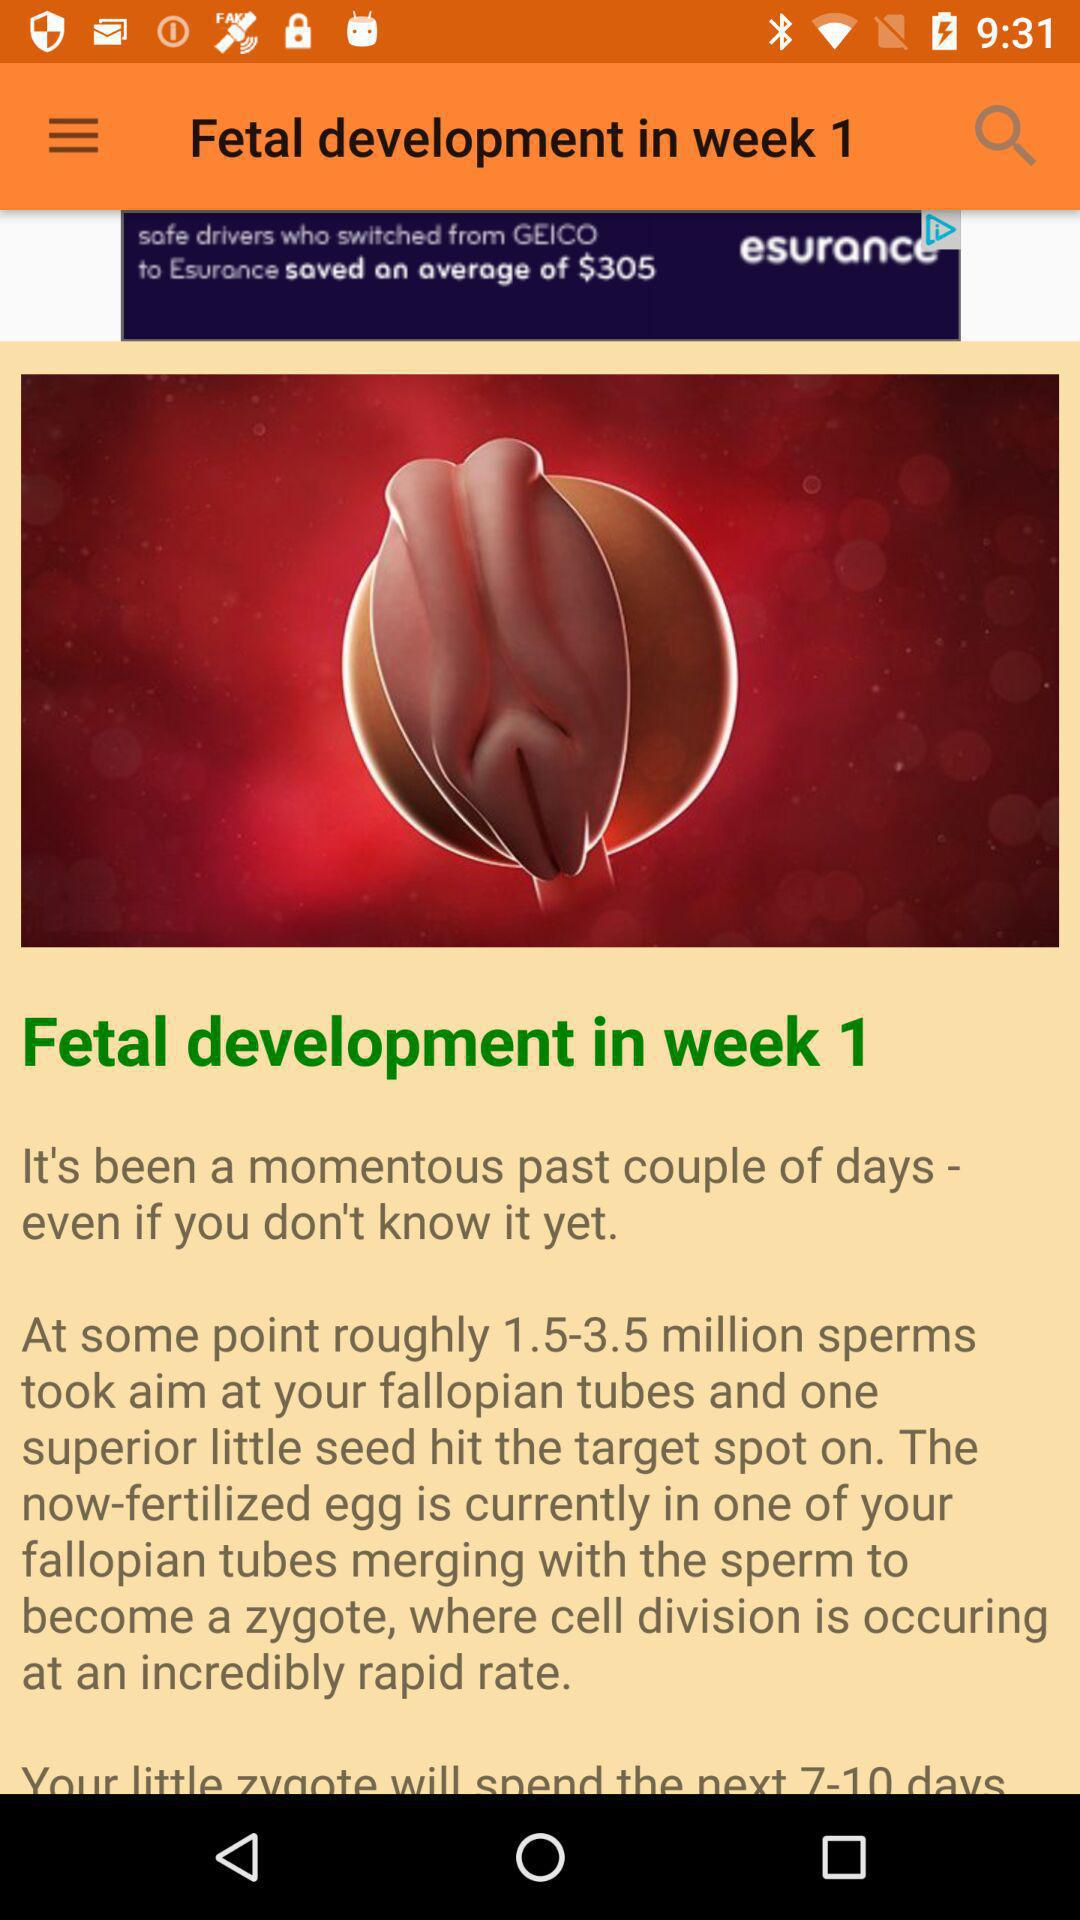How many sperms hit the fallopian tube? There is one superior sperm that hits the fallopian tube. 